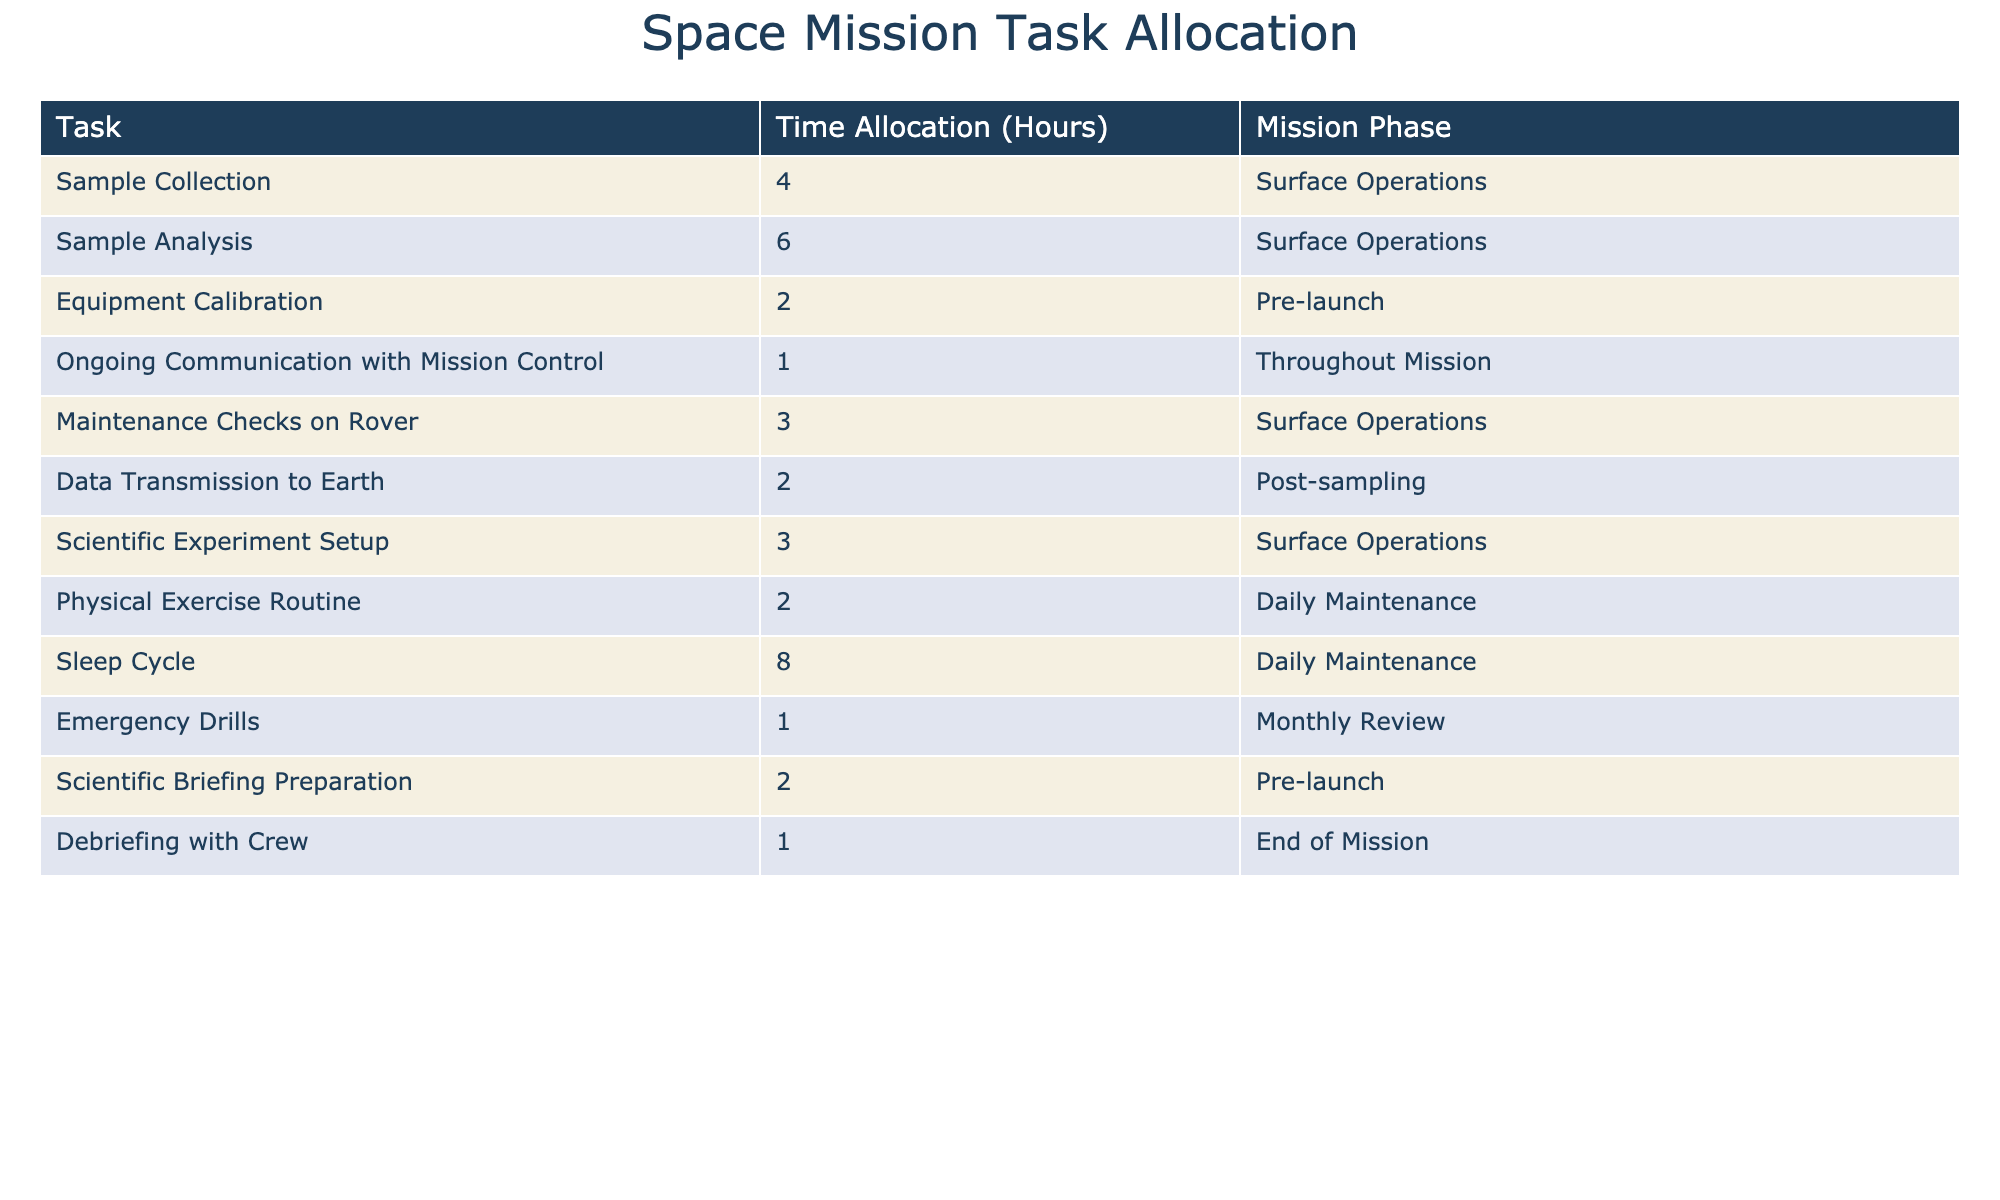What is the total time allocated for Sample Analysis? The table lists Sample Analysis with a time allocation of 6 hours under Surface Operations. Therefore, the total time allocated for Sample Analysis is directly taken from this entry.
Answer: 6 hours How much time is dedicated to equipment-related tasks (Equipment Calibration and Maintenance Checks on Rover)? Equipment Calibration is allocated 2 hours, and Maintenance Checks on Rover are allocated 3 hours. Adding these together gives 2 + 3 = 5 hours dedicated to equipment-related tasks.
Answer: 5 hours Is there a task that requires only 1 hour of time? The table specifies Ongoing Communication with Mission Control and Emergency Drills, both of which require 1 hour. Thus, there are indeed tasks that need only 1 hour.
Answer: Yes What is the total time allocated for tasks in the Surface Operations phase? The tasks listed under Surface Operations are Sample Collection (4 hours), Sample Analysis (6 hours), Maintenance Checks on Rover (3 hours), Scientific Experiment Setup (3 hours), and Ongoing Communication (1 hour). Summing these gives 4 + 6 + 3 + 3 + 1 = 17 hours. Thus, the total time for Surface Operations is 17 hours.
Answer: 17 hours What is the difference in time allocation between the Sleep Cycle and Physical Exercise Routine? The Sleep Cycle is allocated 8 hours while the Physical Exercise Routine is allocated 2 hours. The difference can be calculated as 8 - 2 = 6 hours, indicating how much more time is allocated to the Sleep Cycle compared to Physical Exercise.
Answer: 6 hours 